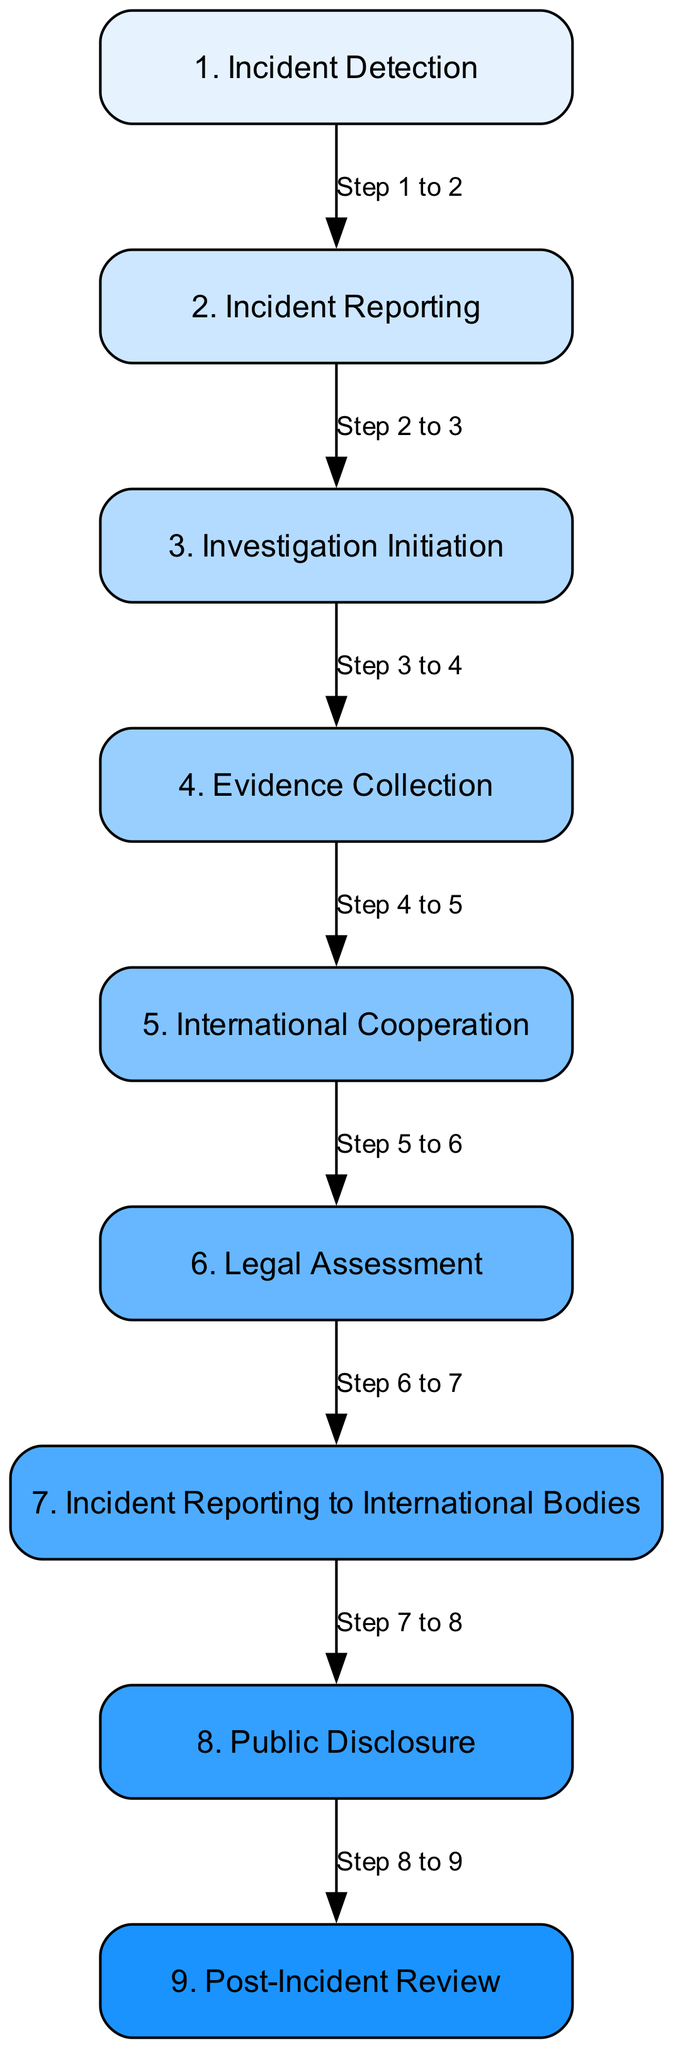What is the first step in the incident workflow? The first step in the workflow, labeled as "1. Incident Detection," represents the initial identification of a cyber incident.
Answer: Incident Detection How many steps are there in the workflow? By counting the numbered list in the diagram, there are nine steps identified in the process.
Answer: Nine What follows after incident reporting? The step that follows "2. Incident Reporting" is "3. Investigation Initiation," indicating that the next action is to begin an investigation.
Answer: Investigation Initiation Which step involves engagement with international organizations? The "5. International Cooperation" step is specifically related to the engagement with international organizations such as INTERPOL and EUROJUST for cross-border incident handling.
Answer: International Cooperation What is the last step in the workflow? "9. Post-Incident Review" is the last step, indicating the comprehensive evaluation of the incident handling and improvements for future responses.
Answer: Post-Incident Review Which steps involve legal considerations? Both "6. Legal Assessment" and "7. Incident Reporting to International Bodies" pertain to legal considerations in the incident reporting and investigation process.
Answer: Legal Assessment, Incident Reporting to International Bodies How many steps are mandatory before public disclosure? There are a total of six steps listed before reaching "8. Public Disclosure," indicating that legal and investigative actions need to be taken beforehand.
Answer: Six What type of assessment is performed in the sixth step? The "6. Legal Assessment" in the workflow represents an evaluation of applicable international laws and conventions related to the cyber incident.
Answer: Legal Assessment What is the primary focus of the fourth step? The primary focus of "4. Evidence Collection" is to gather digital and physical evidence relevant to the cyber incident, which is crucial for the investigation.
Answer: Evidence Collection 